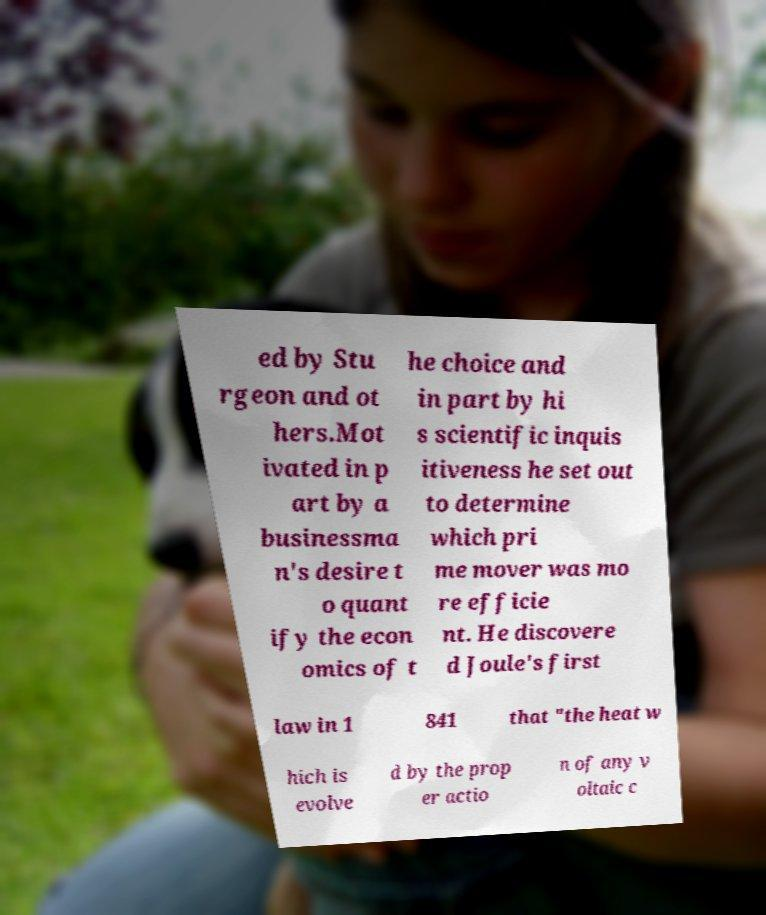For documentation purposes, I need the text within this image transcribed. Could you provide that? ed by Stu rgeon and ot hers.Mot ivated in p art by a businessma n's desire t o quant ify the econ omics of t he choice and in part by hi s scientific inquis itiveness he set out to determine which pri me mover was mo re efficie nt. He discovere d Joule's first law in 1 841 that "the heat w hich is evolve d by the prop er actio n of any v oltaic c 